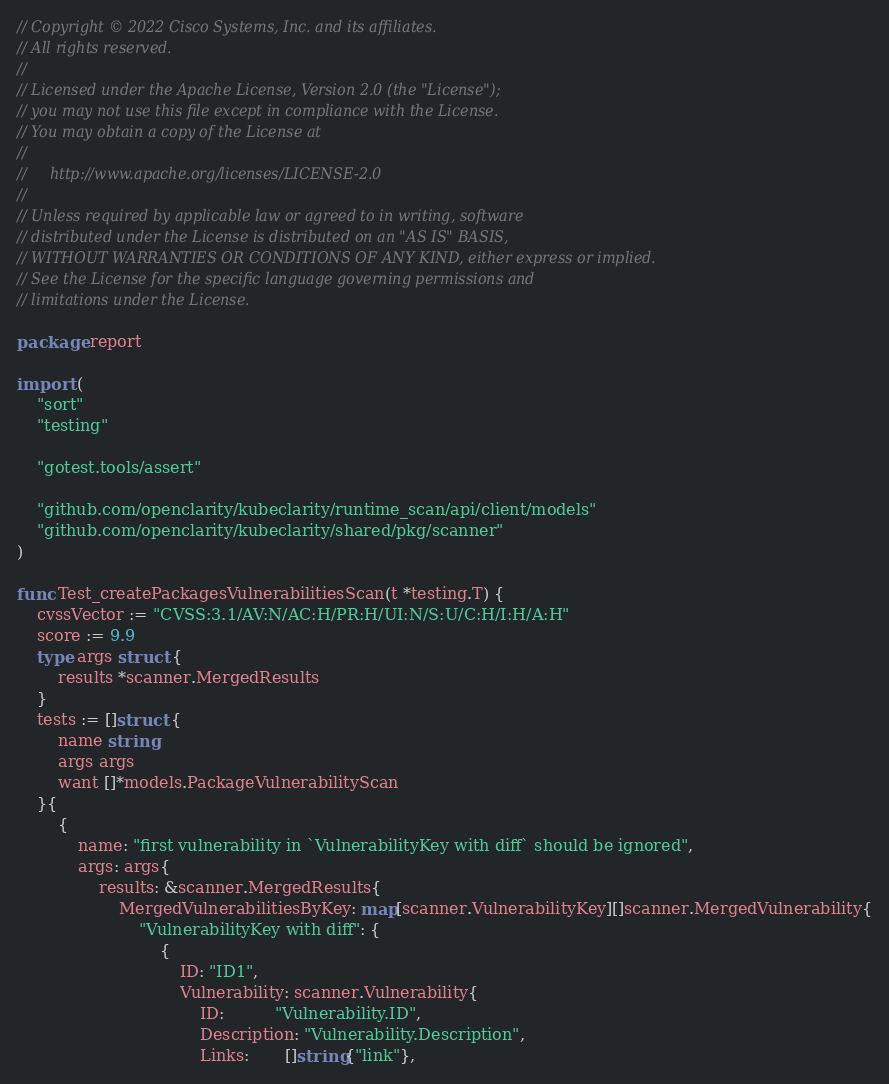Convert code to text. <code><loc_0><loc_0><loc_500><loc_500><_Go_>// Copyright © 2022 Cisco Systems, Inc. and its affiliates.
// All rights reserved.
//
// Licensed under the Apache License, Version 2.0 (the "License");
// you may not use this file except in compliance with the License.
// You may obtain a copy of the License at
//
//     http://www.apache.org/licenses/LICENSE-2.0
//
// Unless required by applicable law or agreed to in writing, software
// distributed under the License is distributed on an "AS IS" BASIS,
// WITHOUT WARRANTIES OR CONDITIONS OF ANY KIND, either express or implied.
// See the License for the specific language governing permissions and
// limitations under the License.

package report

import (
	"sort"
	"testing"

	"gotest.tools/assert"

	"github.com/openclarity/kubeclarity/runtime_scan/api/client/models"
	"github.com/openclarity/kubeclarity/shared/pkg/scanner"
)

func Test_createPackagesVulnerabilitiesScan(t *testing.T) {
	cvssVector := "CVSS:3.1/AV:N/AC:H/PR:H/UI:N/S:U/C:H/I:H/A:H"
	score := 9.9
	type args struct {
		results *scanner.MergedResults
	}
	tests := []struct {
		name string
		args args
		want []*models.PackageVulnerabilityScan
	}{
		{
			name: "first vulnerability in `VulnerabilityKey with diff` should be ignored",
			args: args{
				results: &scanner.MergedResults{
					MergedVulnerabilitiesByKey: map[scanner.VulnerabilityKey][]scanner.MergedVulnerability{
						"VulnerabilityKey with diff": {
							{
								ID: "ID1",
								Vulnerability: scanner.Vulnerability{
									ID:          "Vulnerability.ID",
									Description: "Vulnerability.Description",
									Links:       []string{"link"},</code> 